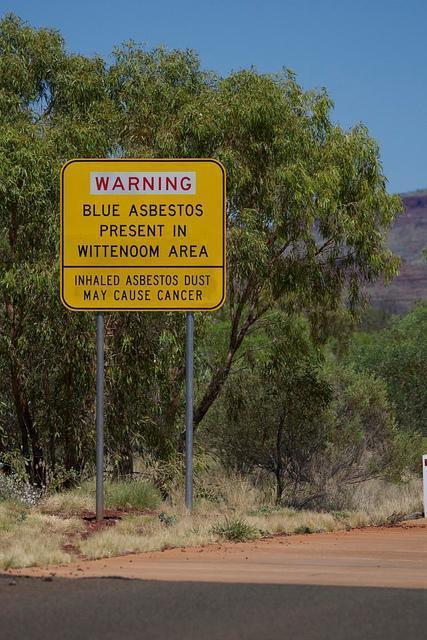How many signs are posted?
Give a very brief answer. 1. 